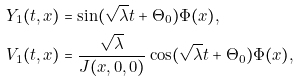Convert formula to latex. <formula><loc_0><loc_0><loc_500><loc_500>Y _ { 1 } ( t , x ) & = \sin ( \sqrt { \lambda } t + \Theta _ { 0 } ) \Phi ( x ) , \\ V _ { 1 } ( t , x ) & = \frac { \sqrt { \lambda } } { J ( x , 0 , 0 ) } \cos ( \sqrt { \lambda } t + \Theta _ { 0 } ) \Phi ( x ) ,</formula> 